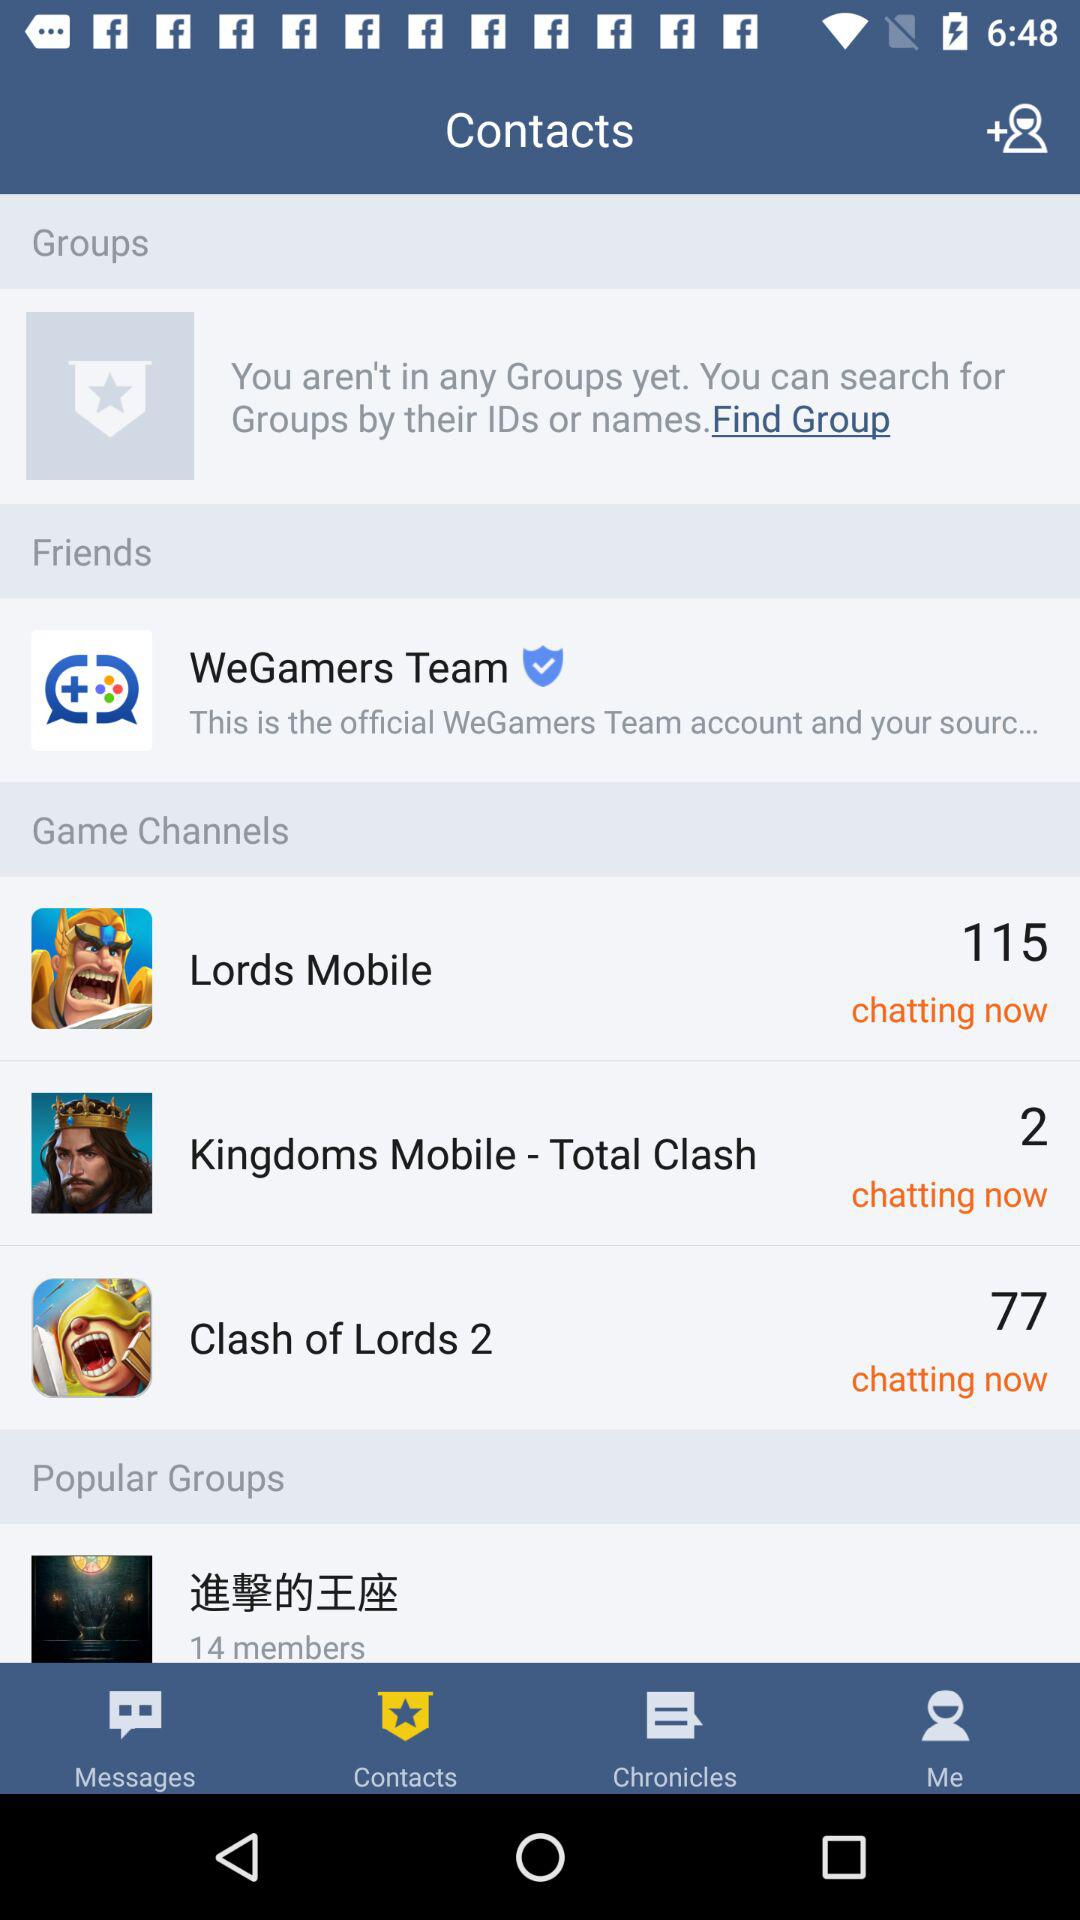What option is in the friends setting? The option is "WeGamers Team". 